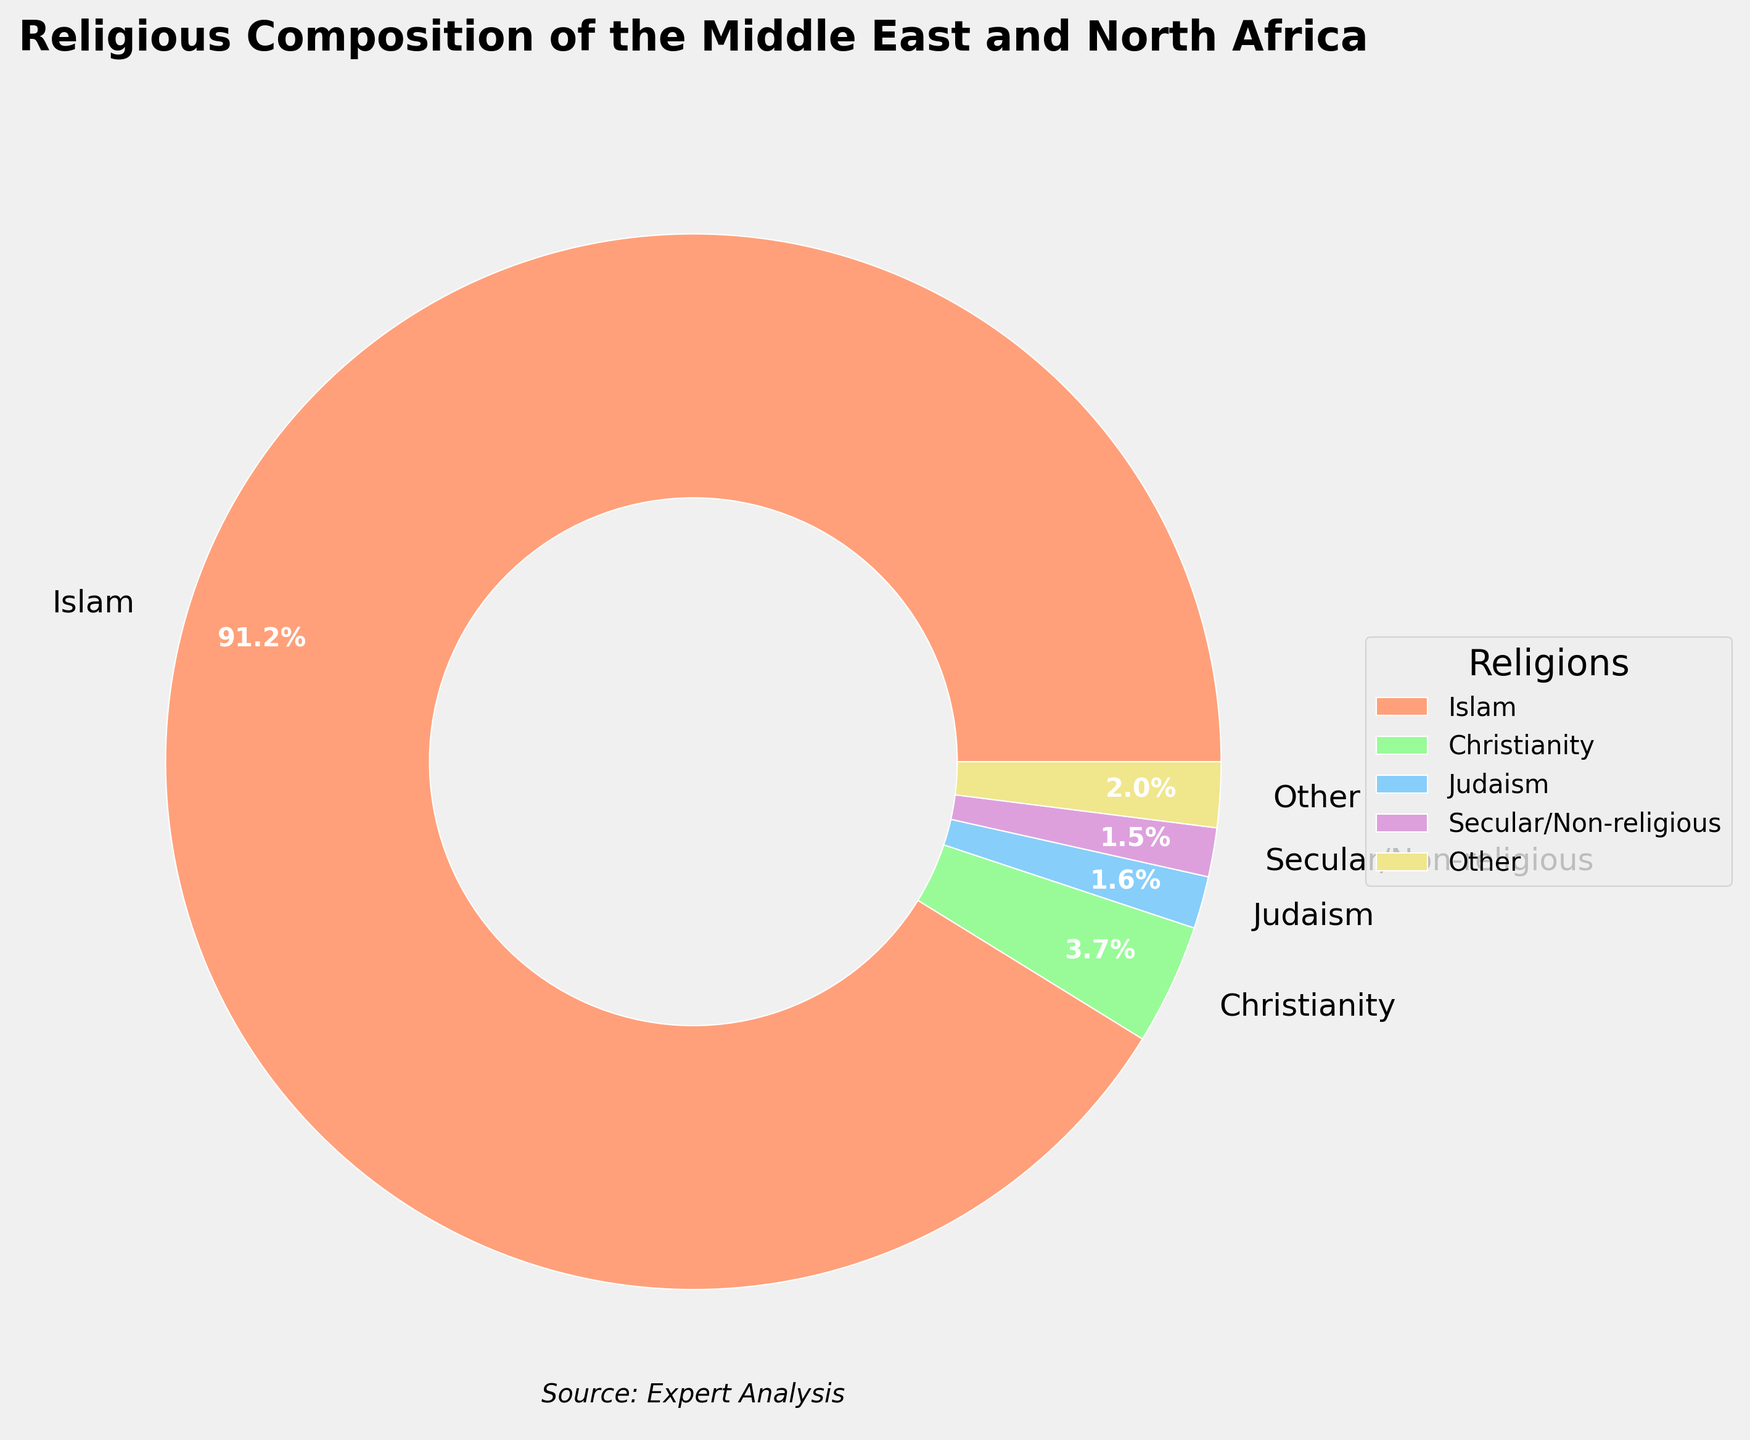Which religion has the highest percentage? By looking at the pie chart, we can see that Islam covers the largest portion of the chart.
Answer: Islam What is the total percentage for religions other than Islam? By summing the percentages of all other religions, 3.7 for Christianity, 1.6 for Judaism, 0.8 for Druze, 1.3 for Other (including Baha'i Faith, Yazidism, Zoroastrianism, Traditional African religions, Secular/Non-religious, and Other), we get 3.7 + 1.6 + 0.8 + 1.3 = 7.4.
Answer: 7.4% Which religion has the second highest percentage, and what is it? Comparing the percentages, Christianity has the second largest section after Islam, with 3.7%.
Answer: Christianity, 3.7% How much larger is the percentage of Islam compared to the combined percentage of all other religions? The percentage of Islam is 91.2%. The combined percentage of all other religions is 7.4%. The difference is 91.2% - 7.4% = 83.8%.
Answer: 83.8% What percentage should be labeled as "Other," and which religions are included in this category? Religions with less than 1% are combined into "Other." Adding their percentages: Traditional African religions (0.4), Baha'i Faith (0.3), Yazidism (0.2), Zoroastrianism (0.1), and Secular/Non-religious (1.5) minus 1.0 = 0.8 (rounded up from 0.75). This totals to approximately 1.3. So, "Other" sums up to 1.3%.
Answer: 1.3%, includes Traditional African religions, Baha'i Faith, Yazidism, Zoroastrianism, Secular/Non-religious Comparing Christianity and Judaism, which one has a higher percentage and by how much? By checking the pie chart, Christianity has 3.7% and Judaism has 1.6%. The difference is 3.7% - 1.6% = 2.1%.
Answer: Christianity, 2.1% What visual attribute is used to distinguish between the different religions in the pie chart? The pie chart uses different colors to distinguish between the different religions.
Answer: Colors 